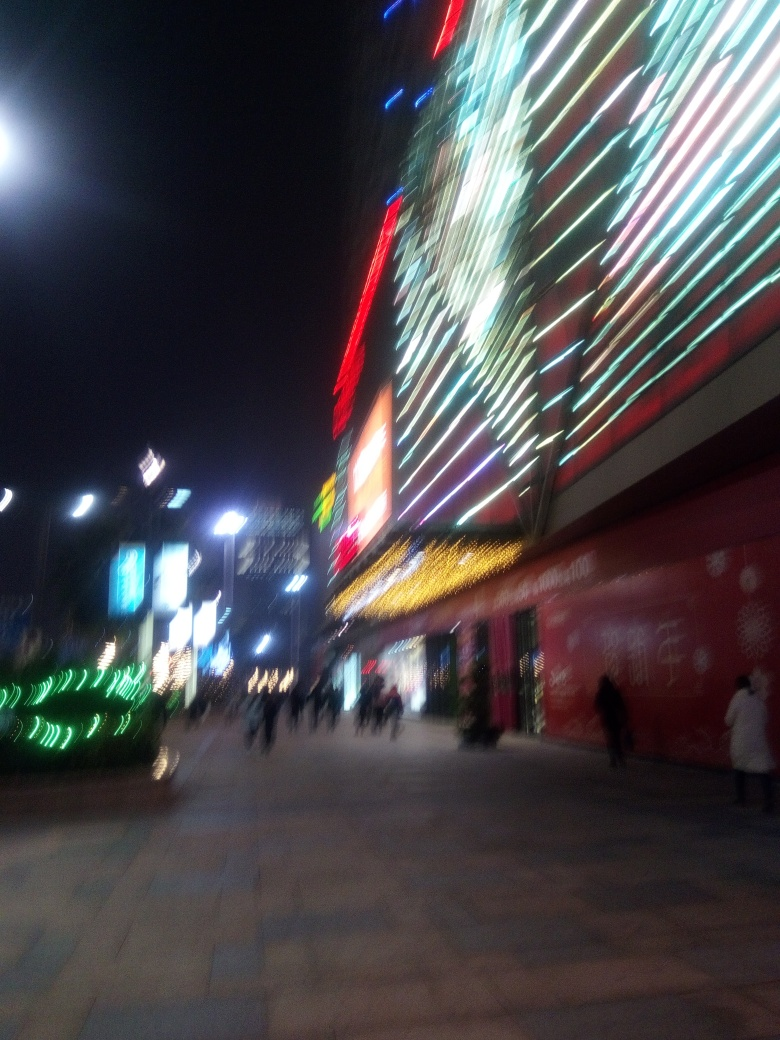What might have caused the photographer to take a picture like this? The photographer may have taken this picture to capture the vibrant energy and the bright lights of the city at night, which can often convey a sense of liveliness and excitement. However, the motion blur suggests the photo was taken hastily or with a moving camera, which could be an artistic choice or an accidental result of shooting handheld without proper stabilization. 